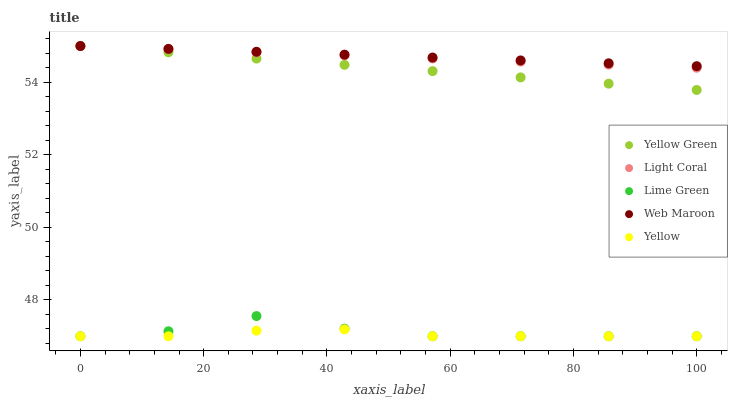Does Yellow have the minimum area under the curve?
Answer yes or no. Yes. Does Web Maroon have the maximum area under the curve?
Answer yes or no. Yes. Does Lime Green have the minimum area under the curve?
Answer yes or no. No. Does Lime Green have the maximum area under the curve?
Answer yes or no. No. Is Web Maroon the smoothest?
Answer yes or no. Yes. Is Lime Green the roughest?
Answer yes or no. Yes. Is Lime Green the smoothest?
Answer yes or no. No. Is Web Maroon the roughest?
Answer yes or no. No. Does Lime Green have the lowest value?
Answer yes or no. Yes. Does Web Maroon have the lowest value?
Answer yes or no. No. Does Yellow Green have the highest value?
Answer yes or no. Yes. Does Lime Green have the highest value?
Answer yes or no. No. Is Yellow less than Web Maroon?
Answer yes or no. Yes. Is Yellow Green greater than Yellow?
Answer yes or no. Yes. Does Yellow Green intersect Web Maroon?
Answer yes or no. Yes. Is Yellow Green less than Web Maroon?
Answer yes or no. No. Is Yellow Green greater than Web Maroon?
Answer yes or no. No. Does Yellow intersect Web Maroon?
Answer yes or no. No. 